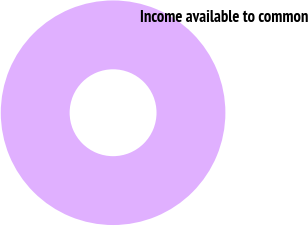Convert chart. <chart><loc_0><loc_0><loc_500><loc_500><pie_chart><fcel>Income available to common<nl><fcel>100.0%<nl></chart> 